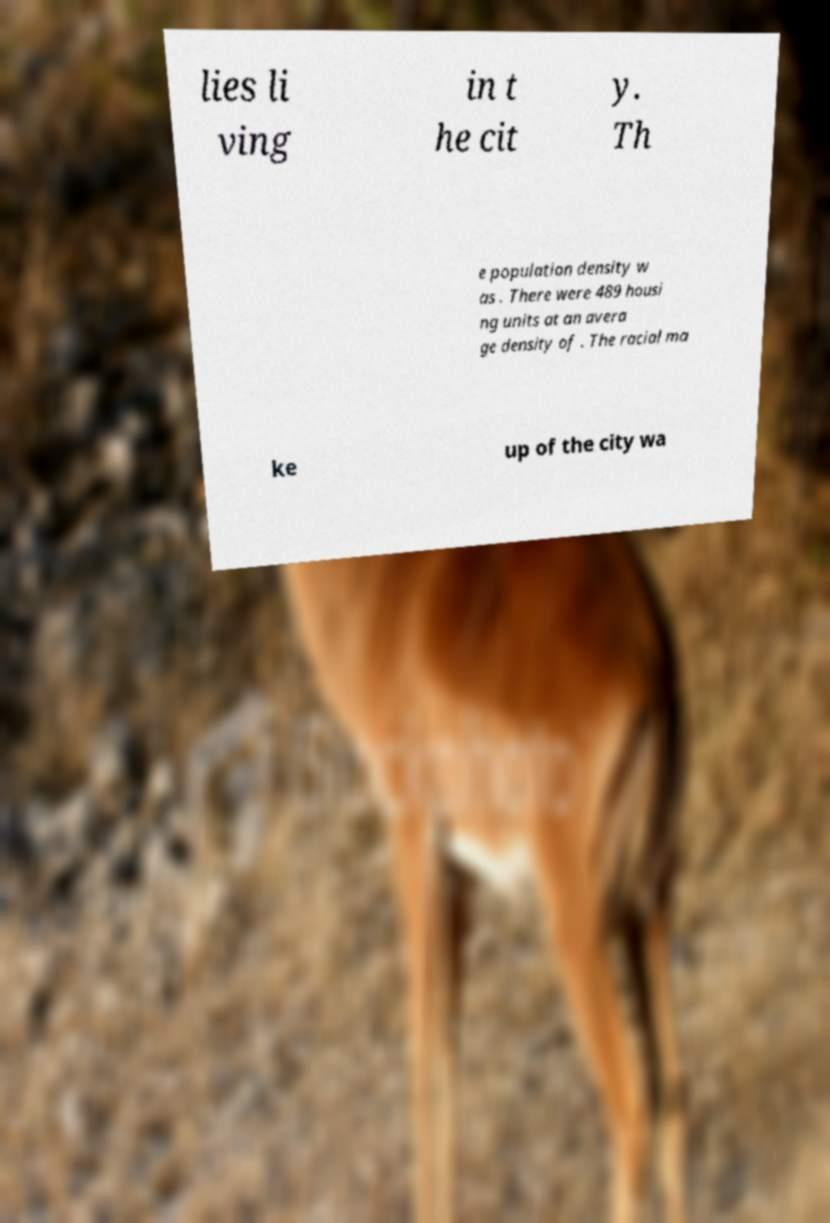There's text embedded in this image that I need extracted. Can you transcribe it verbatim? lies li ving in t he cit y. Th e population density w as . There were 489 housi ng units at an avera ge density of . The racial ma ke up of the city wa 